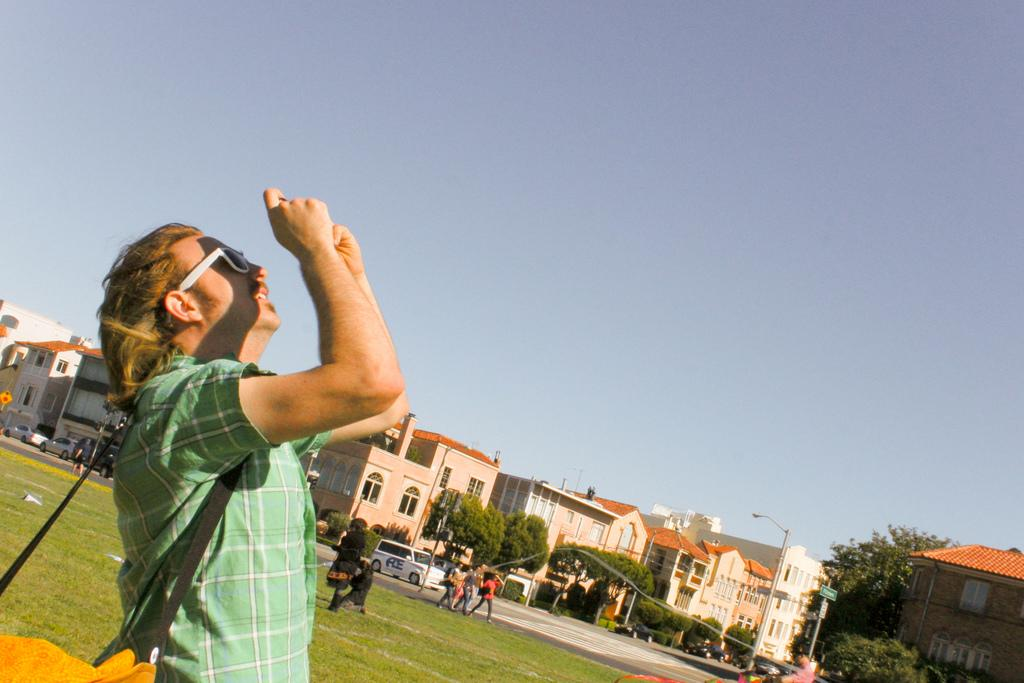What is the main subject of the image? There is a man standing in the image. Can you describe what the man is wearing? The man is wearing a bag. What can be seen in the background of the image? There are buildings, trees, poles, and the sky visible in the background of the image. What is happening in the center of the image? There are people and cars on the road in the center of the image. What type of hill can be seen in the background of the image? There is no hill present in the background of the image; it features buildings, trees, poles, and the sky. How many buttons are visible on the man's bag in the image? There is no mention of buttons on the man's bag in the provided facts, so we cannot determine the number of buttons. 